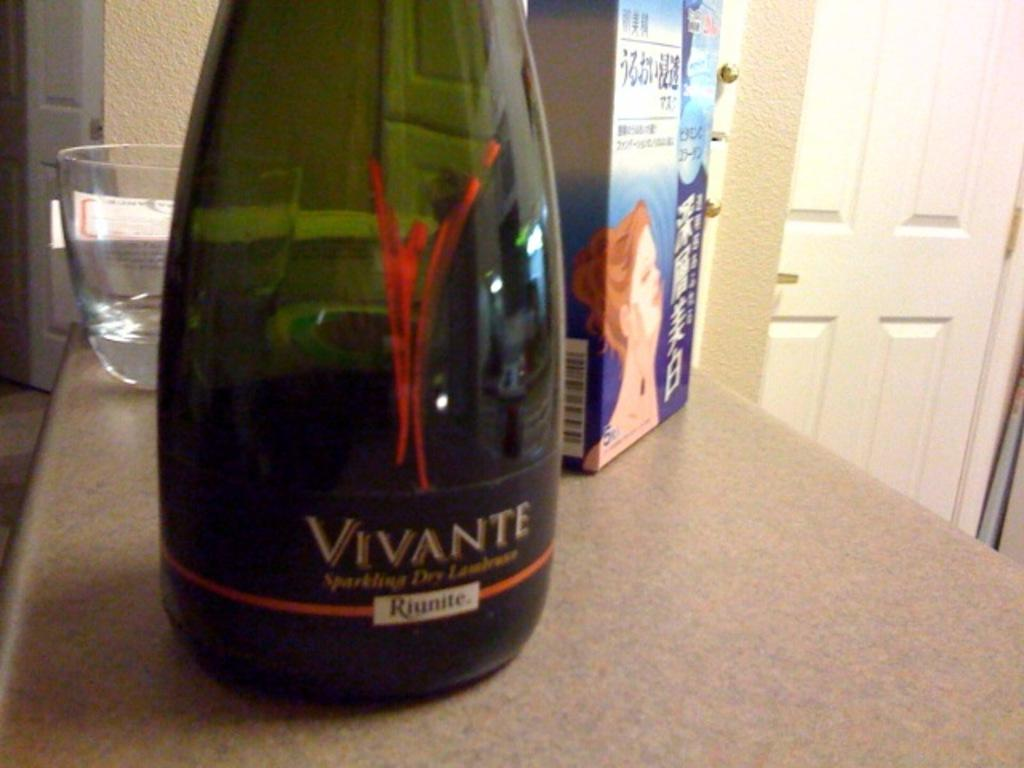<image>
Share a concise interpretation of the image provided. a green bottle of vivante sparkling dry riunite 